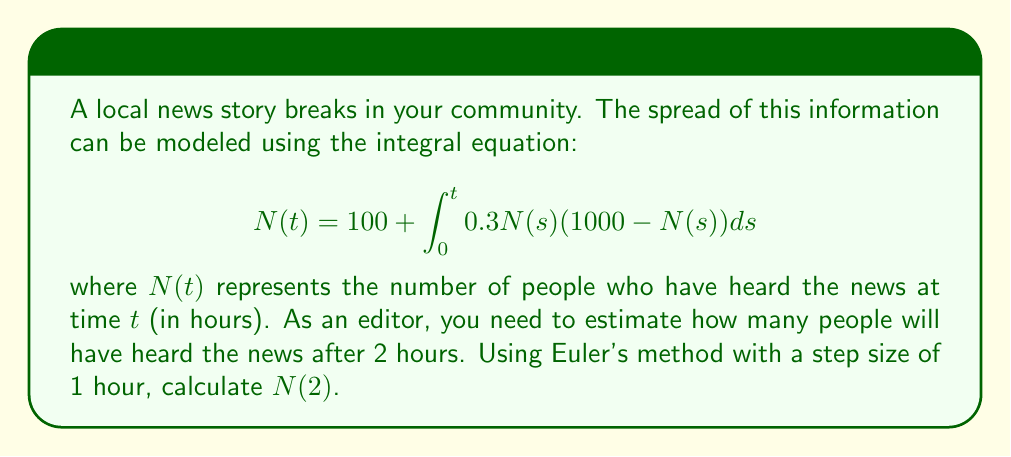Show me your answer to this math problem. To solve this problem using Euler's method, we'll follow these steps:

1) Euler's method for integral equations is given by:
   $$N(t_{i+1}) = N(t_i) + h \cdot f(t_i, N(t_i))$$
   where $h$ is the step size and $f(t, N(t)) = 0.3N(t)(1000-N(t))$

2) We're given:
   - Initial condition: $N(0) = 100$
   - Step size: $h = 1$ hour
   - We need to calculate $N(2)$

3) First, let's calculate $N(1)$:
   $$N(1) = N(0) + h \cdot f(0, N(0))$$
   $$= 100 + 1 \cdot 0.3 \cdot 100 \cdot (1000-100)$$
   $$= 100 + 27000 = 27100$$

4) Now, let's calculate $N(2)$:
   $$N(2) = N(1) + h \cdot f(1, N(1))$$
   $$= 27100 + 1 \cdot 0.3 \cdot 27100 \cdot (1000-27100)$$
   $$= 27100 + 5937900 = 5965000$$

5) Therefore, after 2 hours, approximately 5,965,000 people will have heard the news according to this model.
Answer: 5,965,000 people 